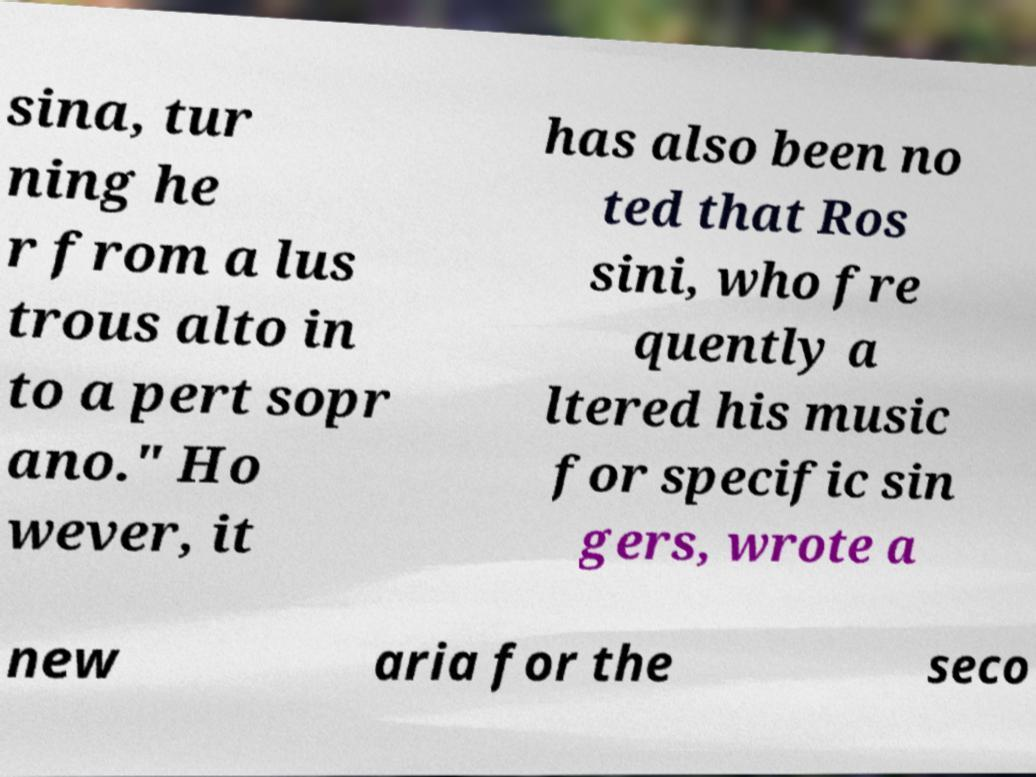What messages or text are displayed in this image? I need them in a readable, typed format. sina, tur ning he r from a lus trous alto in to a pert sopr ano." Ho wever, it has also been no ted that Ros sini, who fre quently a ltered his music for specific sin gers, wrote a new aria for the seco 